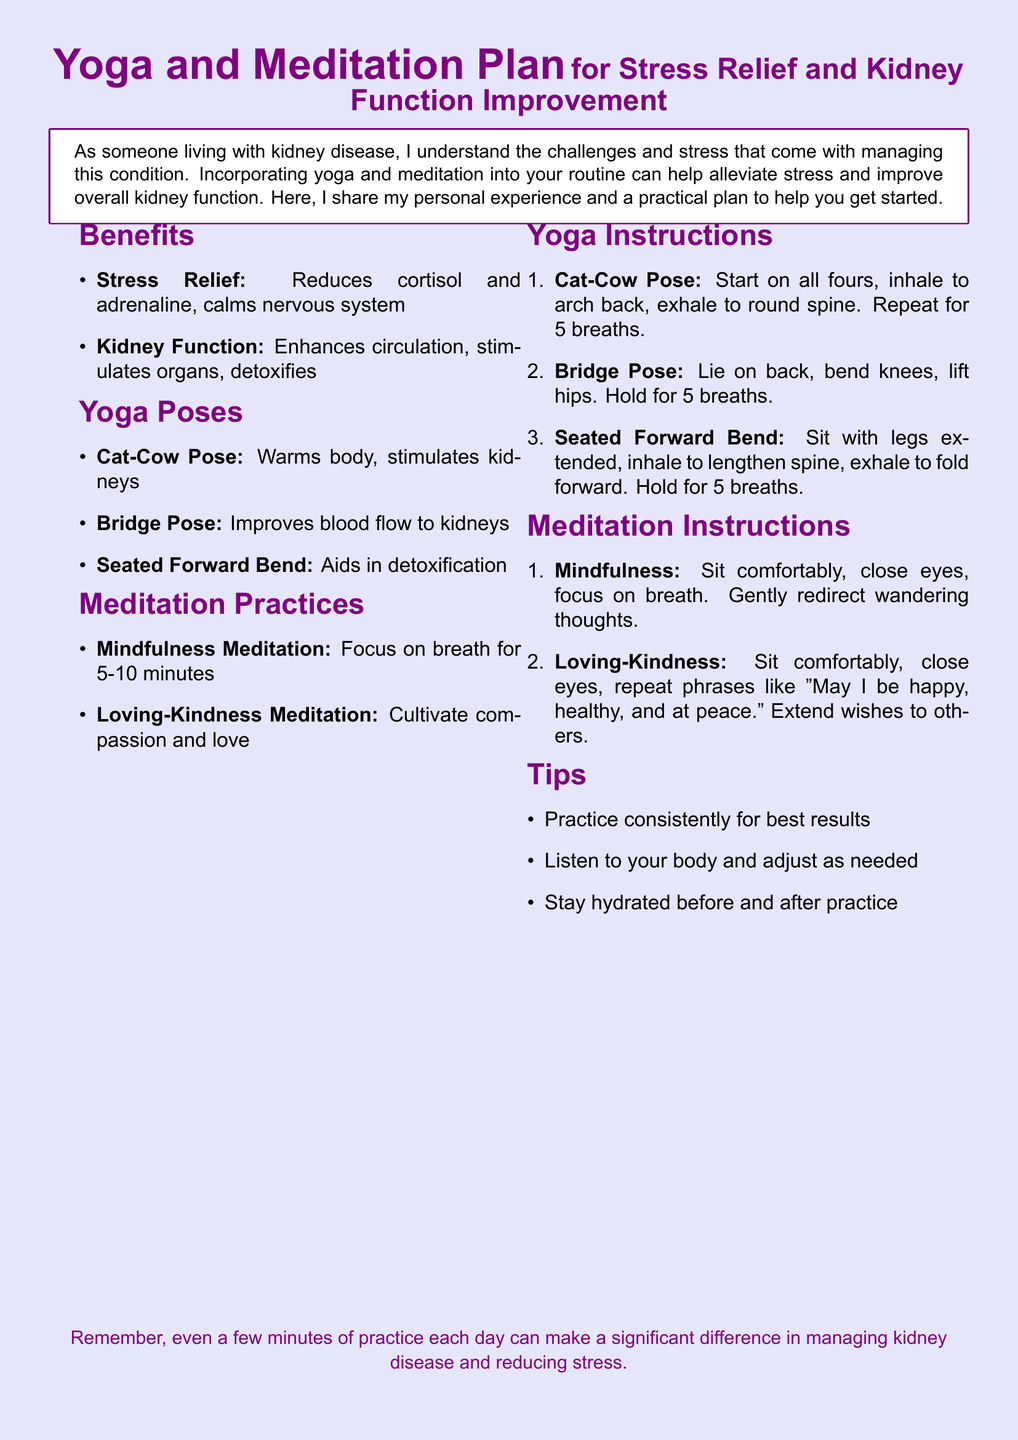What are the benefits of yoga for kidney function? The benefits listed for yoga in relation to kidney function include enhanced circulation, stimulation of organs, and detoxification.
Answer: Enhances circulation, stimulates organs, detoxifies How long should mindfulness meditation be practiced? The document states that mindfulness meditation should be focused on for 5-10 minutes.
Answer: 5-10 minutes Which yoga pose aids in detoxification? The document specifies that the Seated Forward Bend helps in detoxification.
Answer: Seated Forward Bend What is the instruction for the Cat-Cow Pose? The instruction details that you start on all fours, inhale to arch back, and exhale to round the spine, repeating for 5 breaths.
Answer: Start on all fours, inhale to arch back, exhale to round spine. Repeat for 5 breaths What is one of the tips mentioned for practicing yoga and meditation? The document mentions practicing consistently for best results as one of the tips.
Answer: Practice consistently for best results What is the primary focus during mindfulness meditation? The primary focus during mindfulness meditation is to focus on breath.
Answer: Focus on breath 